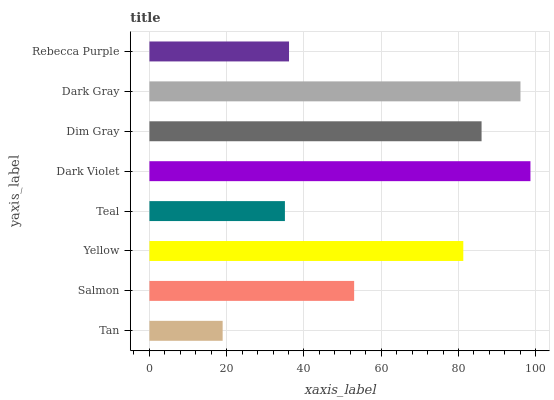Is Tan the minimum?
Answer yes or no. Yes. Is Dark Violet the maximum?
Answer yes or no. Yes. Is Salmon the minimum?
Answer yes or no. No. Is Salmon the maximum?
Answer yes or no. No. Is Salmon greater than Tan?
Answer yes or no. Yes. Is Tan less than Salmon?
Answer yes or no. Yes. Is Tan greater than Salmon?
Answer yes or no. No. Is Salmon less than Tan?
Answer yes or no. No. Is Yellow the high median?
Answer yes or no. Yes. Is Salmon the low median?
Answer yes or no. Yes. Is Teal the high median?
Answer yes or no. No. Is Tan the low median?
Answer yes or no. No. 